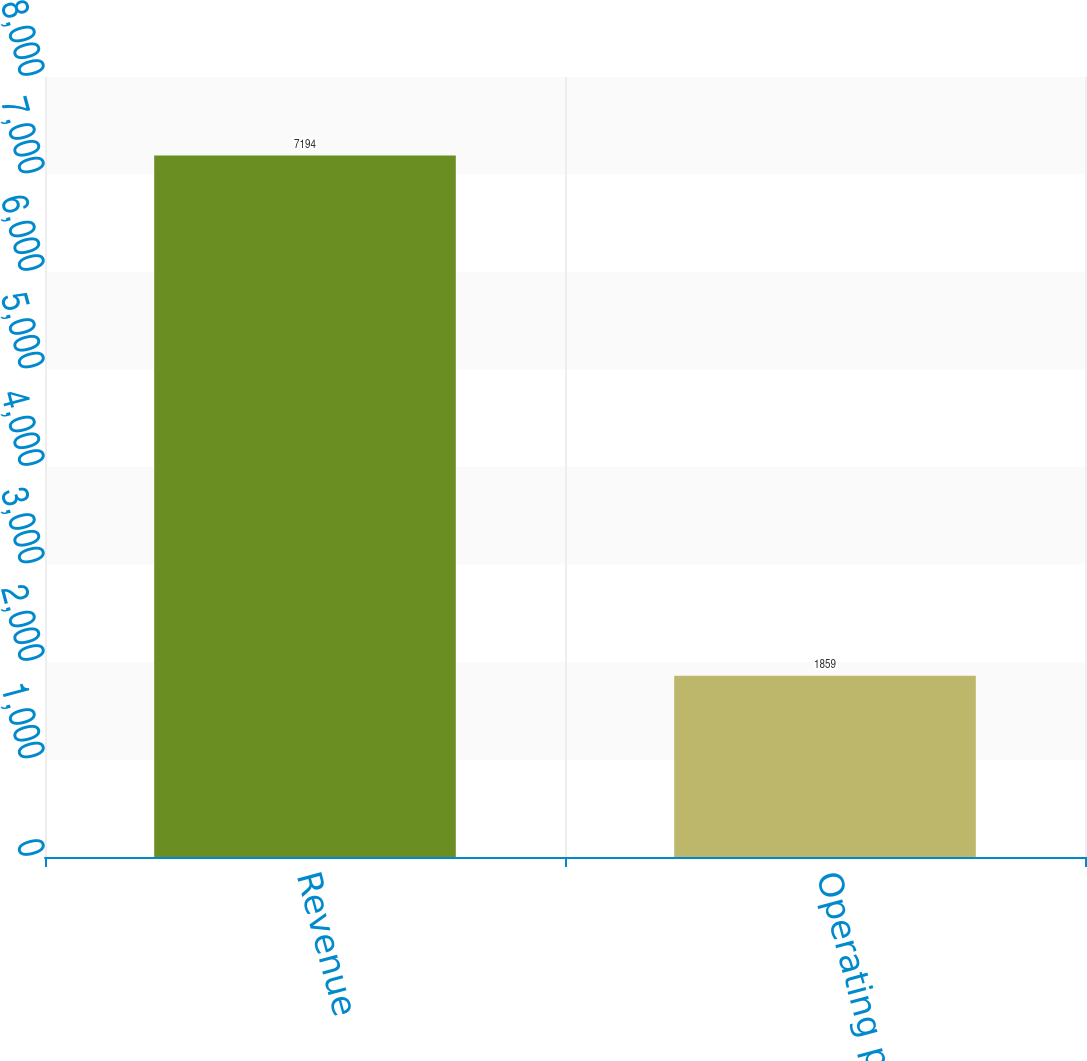Convert chart. <chart><loc_0><loc_0><loc_500><loc_500><bar_chart><fcel>Revenue<fcel>Operating profit<nl><fcel>7194<fcel>1859<nl></chart> 